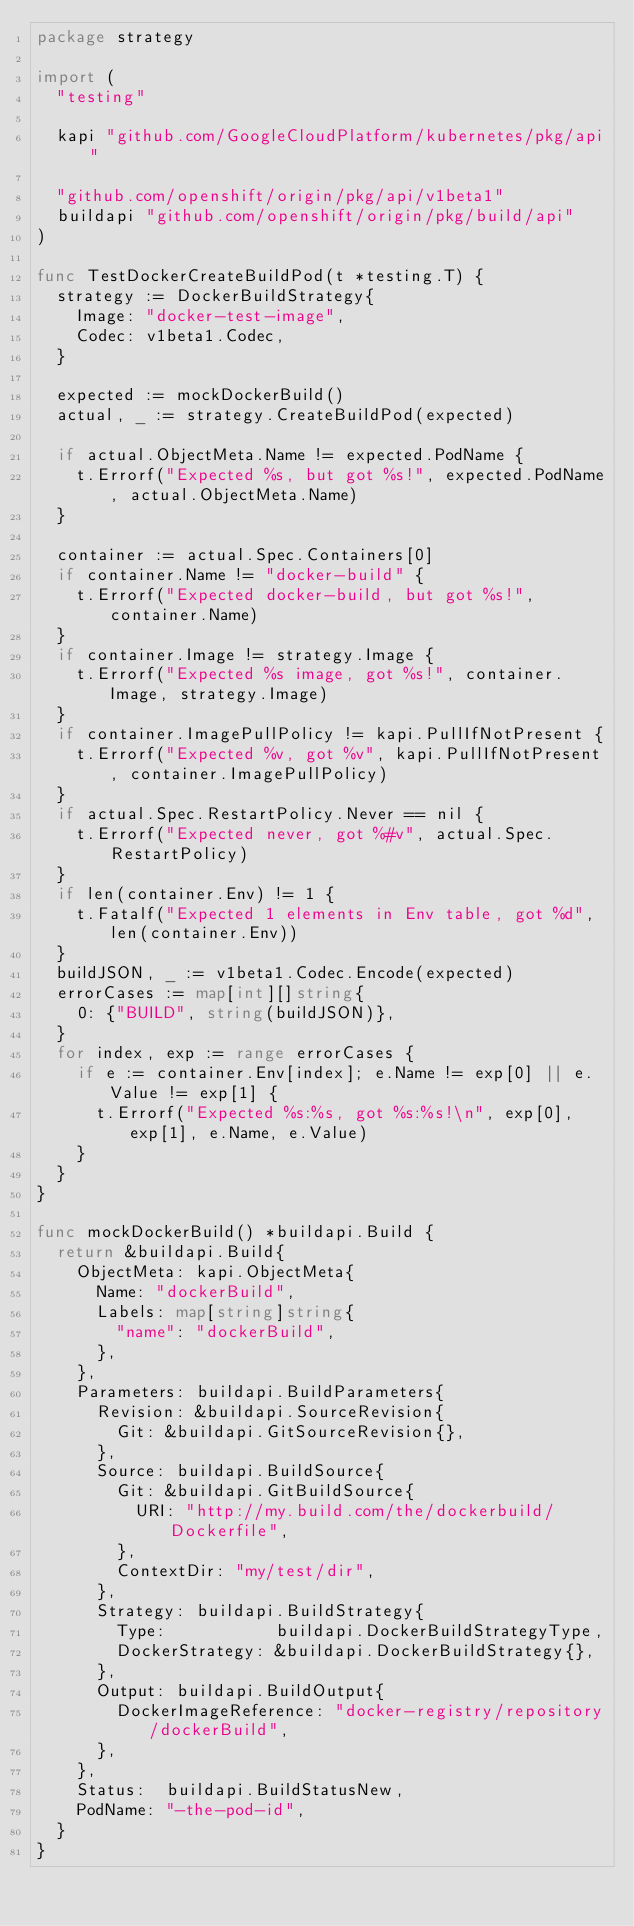Convert code to text. <code><loc_0><loc_0><loc_500><loc_500><_Go_>package strategy

import (
	"testing"

	kapi "github.com/GoogleCloudPlatform/kubernetes/pkg/api"

	"github.com/openshift/origin/pkg/api/v1beta1"
	buildapi "github.com/openshift/origin/pkg/build/api"
)

func TestDockerCreateBuildPod(t *testing.T) {
	strategy := DockerBuildStrategy{
		Image: "docker-test-image",
		Codec: v1beta1.Codec,
	}

	expected := mockDockerBuild()
	actual, _ := strategy.CreateBuildPod(expected)

	if actual.ObjectMeta.Name != expected.PodName {
		t.Errorf("Expected %s, but got %s!", expected.PodName, actual.ObjectMeta.Name)
	}

	container := actual.Spec.Containers[0]
	if container.Name != "docker-build" {
		t.Errorf("Expected docker-build, but got %s!", container.Name)
	}
	if container.Image != strategy.Image {
		t.Errorf("Expected %s image, got %s!", container.Image, strategy.Image)
	}
	if container.ImagePullPolicy != kapi.PullIfNotPresent {
		t.Errorf("Expected %v, got %v", kapi.PullIfNotPresent, container.ImagePullPolicy)
	}
	if actual.Spec.RestartPolicy.Never == nil {
		t.Errorf("Expected never, got %#v", actual.Spec.RestartPolicy)
	}
	if len(container.Env) != 1 {
		t.Fatalf("Expected 1 elements in Env table, got %d", len(container.Env))
	}
	buildJSON, _ := v1beta1.Codec.Encode(expected)
	errorCases := map[int][]string{
		0: {"BUILD", string(buildJSON)},
	}
	for index, exp := range errorCases {
		if e := container.Env[index]; e.Name != exp[0] || e.Value != exp[1] {
			t.Errorf("Expected %s:%s, got %s:%s!\n", exp[0], exp[1], e.Name, e.Value)
		}
	}
}

func mockDockerBuild() *buildapi.Build {
	return &buildapi.Build{
		ObjectMeta: kapi.ObjectMeta{
			Name: "dockerBuild",
			Labels: map[string]string{
				"name": "dockerBuild",
			},
		},
		Parameters: buildapi.BuildParameters{
			Revision: &buildapi.SourceRevision{
				Git: &buildapi.GitSourceRevision{},
			},
			Source: buildapi.BuildSource{
				Git: &buildapi.GitBuildSource{
					URI: "http://my.build.com/the/dockerbuild/Dockerfile",
				},
				ContextDir: "my/test/dir",
			},
			Strategy: buildapi.BuildStrategy{
				Type:           buildapi.DockerBuildStrategyType,
				DockerStrategy: &buildapi.DockerBuildStrategy{},
			},
			Output: buildapi.BuildOutput{
				DockerImageReference: "docker-registry/repository/dockerBuild",
			},
		},
		Status:  buildapi.BuildStatusNew,
		PodName: "-the-pod-id",
	}
}
</code> 